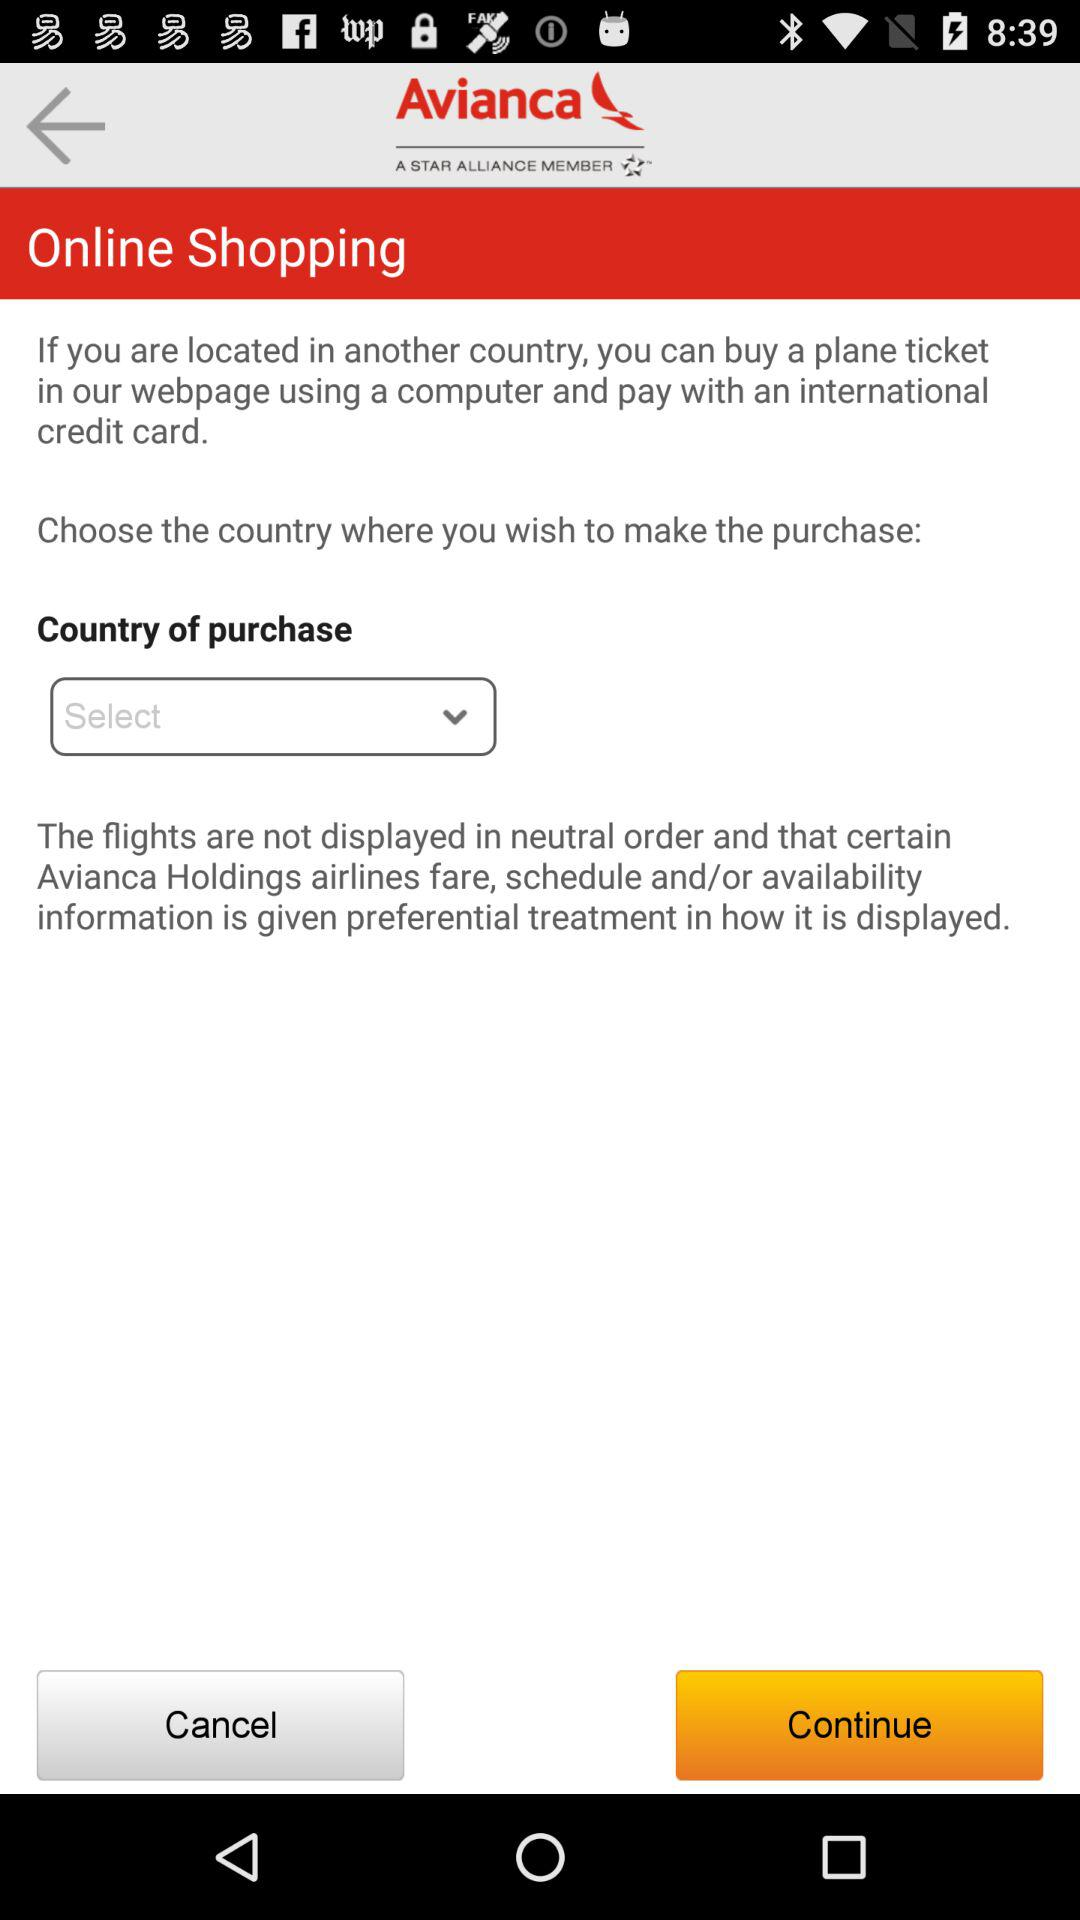What is the name of the application? The name of the application is "Avianca". 